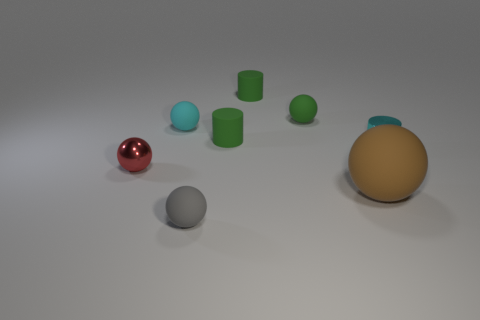The brown object has what shape?
Provide a succinct answer. Sphere. There is a big ball that is made of the same material as the tiny green ball; what color is it?
Give a very brief answer. Brown. Are there more green objects than large green cylinders?
Keep it short and to the point. Yes. Are there any green cylinders?
Make the answer very short. Yes. There is a small metallic object that is to the right of the tiny sphere right of the gray rubber object; what shape is it?
Provide a short and direct response. Cylinder. How many objects are either small cyan rubber objects or tiny matte balls that are behind the gray rubber thing?
Ensure brevity in your answer.  2. There is a matte cylinder that is in front of the cyan object behind the tiny cyan shiny cylinder that is behind the brown object; what is its color?
Keep it short and to the point. Green. There is a red object that is the same shape as the cyan rubber object; what is it made of?
Offer a terse response. Metal. What is the color of the large ball?
Provide a succinct answer. Brown. Do the big object and the shiny ball have the same color?
Your answer should be very brief. No. 